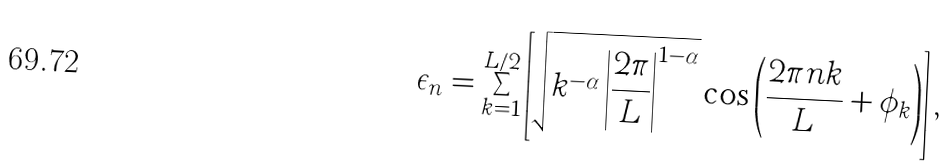Convert formula to latex. <formula><loc_0><loc_0><loc_500><loc_500>\epsilon _ { n } = \sum _ { k = 1 } ^ { L / 2 } \left [ \sqrt { k ^ { - \alpha } \left | \frac { 2 \pi } { L } \right | ^ { 1 - \alpha } } \cos \left ( \frac { 2 \pi n k } { L } + \phi _ { k } \right ) \right ] ,</formula> 